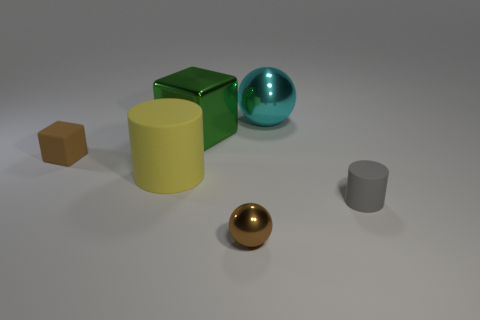Add 3 cyan metallic objects. How many objects exist? 9 Subtract all yellow cylinders. How many cylinders are left? 1 Subtract all blocks. How many objects are left? 4 Subtract all small shiny things. Subtract all big cyan metallic objects. How many objects are left? 4 Add 4 yellow matte things. How many yellow matte things are left? 5 Add 4 metal cubes. How many metal cubes exist? 5 Subtract 0 green cylinders. How many objects are left? 6 Subtract 1 cylinders. How many cylinders are left? 1 Subtract all blue balls. Subtract all cyan cubes. How many balls are left? 2 Subtract all cyan balls. How many gray cylinders are left? 1 